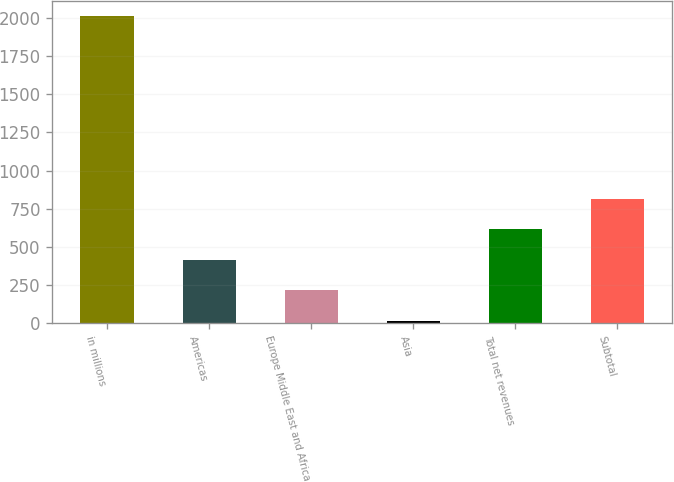<chart> <loc_0><loc_0><loc_500><loc_500><bar_chart><fcel>in millions<fcel>Americas<fcel>Europe Middle East and Africa<fcel>Asia<fcel>Total net revenues<fcel>Subtotal<nl><fcel>2013<fcel>415.4<fcel>215.7<fcel>16<fcel>615.1<fcel>814.8<nl></chart> 